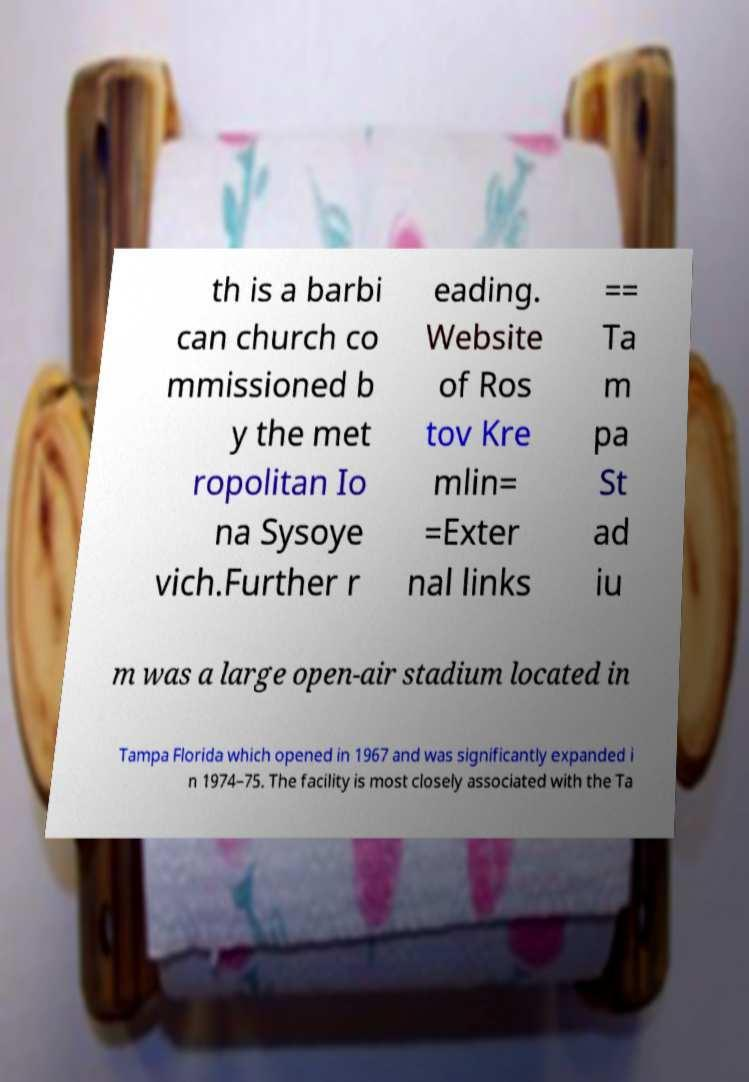There's text embedded in this image that I need extracted. Can you transcribe it verbatim? th is a barbi can church co mmissioned b y the met ropolitan Io na Sysoye vich.Further r eading. Website of Ros tov Kre mlin= =Exter nal links == Ta m pa St ad iu m was a large open-air stadium located in Tampa Florida which opened in 1967 and was significantly expanded i n 1974–75. The facility is most closely associated with the Ta 